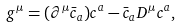<formula> <loc_0><loc_0><loc_500><loc_500>g ^ { \mu } = ( \partial ^ { \mu } \bar { c } _ { a } ) c ^ { a } - \bar { c } _ { a } D ^ { \mu } c ^ { a } ,</formula> 